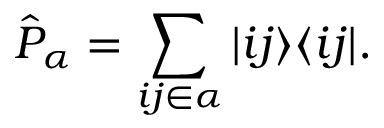<formula> <loc_0><loc_0><loc_500><loc_500>\hat { P } _ { \alpha } = \sum _ { i j \in \alpha } | i j \rangle \langle i j | .</formula> 